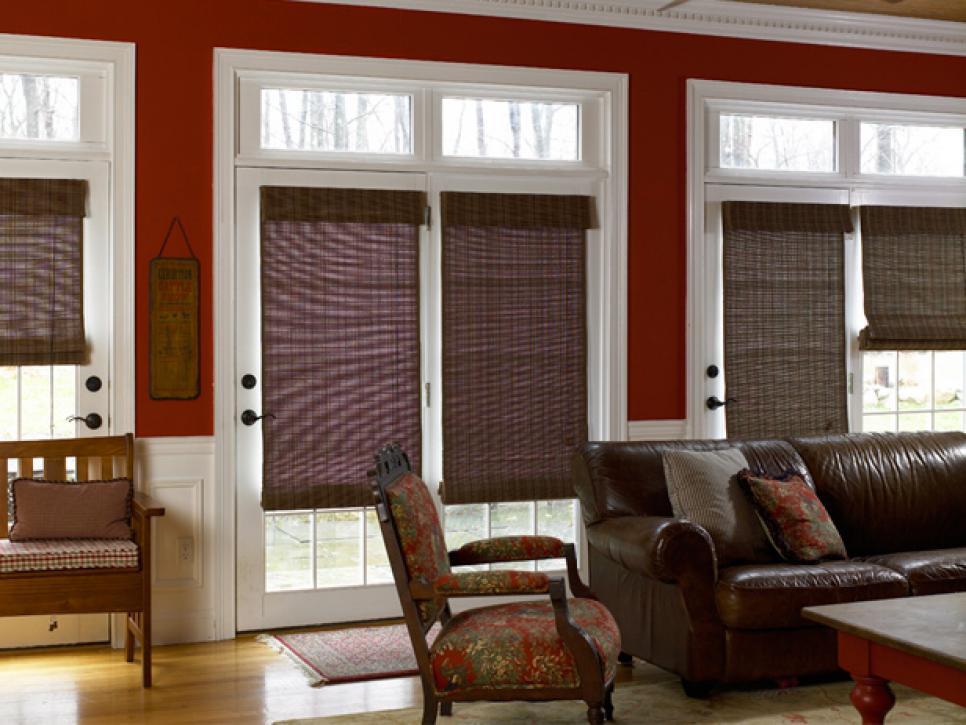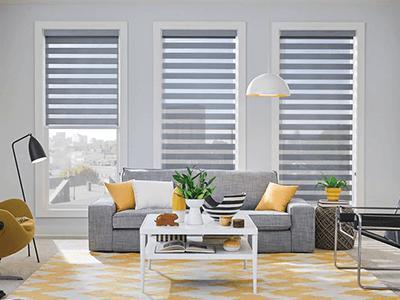The first image is the image on the left, the second image is the image on the right. Analyze the images presented: Is the assertion "There is at least one plant in the right image" valid? Answer yes or no. Yes. The first image is the image on the left, the second image is the image on the right. Examine the images to the left and right. Is the description "In at least one image there are three blinds with two at the same height." accurate? Answer yes or no. Yes. 